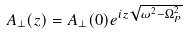<formula> <loc_0><loc_0><loc_500><loc_500>A _ { \perp } ( z ) = A _ { \perp } ( 0 ) e ^ { i z \sqrt { \omega ^ { 2 } - \Omega _ { p } ^ { 2 } } }</formula> 